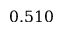Convert formula to latex. <formula><loc_0><loc_0><loc_500><loc_500>0 . 5 1 0</formula> 